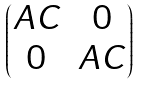Convert formula to latex. <formula><loc_0><loc_0><loc_500><loc_500>\begin{pmatrix} A C & 0 \\ 0 & A C \end{pmatrix}</formula> 